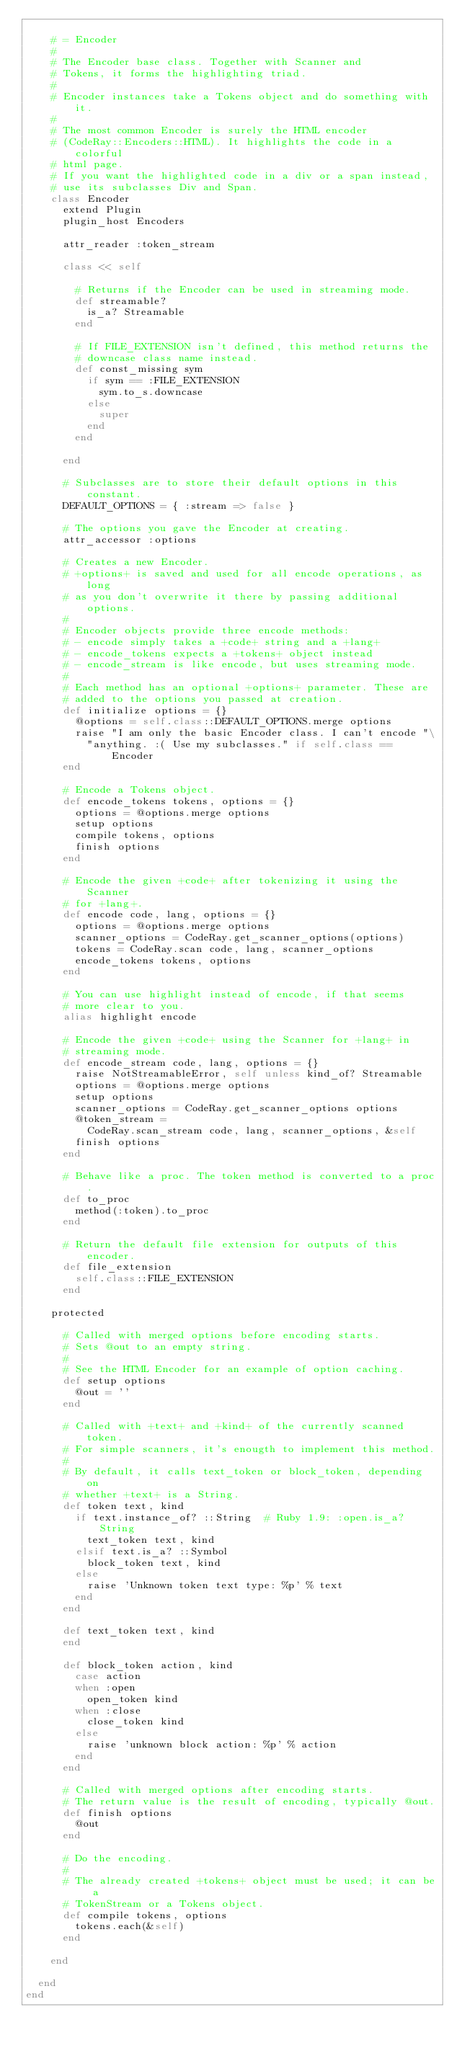Convert code to text. <code><loc_0><loc_0><loc_500><loc_500><_Ruby_>
    # = Encoder
    #
    # The Encoder base class. Together with Scanner and
    # Tokens, it forms the highlighting triad.
    #
    # Encoder instances take a Tokens object and do something with it.
    #
    # The most common Encoder is surely the HTML encoder
    # (CodeRay::Encoders::HTML). It highlights the code in a colorful
    # html page.
    # If you want the highlighted code in a div or a span instead,
    # use its subclasses Div and Span.
    class Encoder
      extend Plugin
      plugin_host Encoders

      attr_reader :token_stream

      class << self

        # Returns if the Encoder can be used in streaming mode.
        def streamable?
          is_a? Streamable
        end

        # If FILE_EXTENSION isn't defined, this method returns the
        # downcase class name instead.
        def const_missing sym
          if sym == :FILE_EXTENSION
            sym.to_s.downcase
          else
            super
          end
        end

      end

      # Subclasses are to store their default options in this constant.
      DEFAULT_OPTIONS = { :stream => false }

      # The options you gave the Encoder at creating.
      attr_accessor :options

      # Creates a new Encoder.
      # +options+ is saved and used for all encode operations, as long
      # as you don't overwrite it there by passing additional options.
      #
      # Encoder objects provide three encode methods:
      # - encode simply takes a +code+ string and a +lang+
      # - encode_tokens expects a +tokens+ object instead
      # - encode_stream is like encode, but uses streaming mode.
      #
      # Each method has an optional +options+ parameter. These are
      # added to the options you passed at creation.
      def initialize options = {}
        @options = self.class::DEFAULT_OPTIONS.merge options
        raise "I am only the basic Encoder class. I can't encode "\
          "anything. :( Use my subclasses." if self.class == Encoder
      end

      # Encode a Tokens object.
      def encode_tokens tokens, options = {}
        options = @options.merge options
        setup options
        compile tokens, options
        finish options
      end

      # Encode the given +code+ after tokenizing it using the Scanner
      # for +lang+.
      def encode code, lang, options = {}
        options = @options.merge options
        scanner_options = CodeRay.get_scanner_options(options)
        tokens = CodeRay.scan code, lang, scanner_options
        encode_tokens tokens, options
      end

      # You can use highlight instead of encode, if that seems
      # more clear to you.
      alias highlight encode

      # Encode the given +code+ using the Scanner for +lang+ in
      # streaming mode.
      def encode_stream code, lang, options = {}
        raise NotStreamableError, self unless kind_of? Streamable
        options = @options.merge options
        setup options
        scanner_options = CodeRay.get_scanner_options options
        @token_stream =
          CodeRay.scan_stream code, lang, scanner_options, &self
        finish options
      end

      # Behave like a proc. The token method is converted to a proc.
      def to_proc
        method(:token).to_proc
      end

      # Return the default file extension for outputs of this encoder.
      def file_extension
        self.class::FILE_EXTENSION
      end

    protected

      # Called with merged options before encoding starts.
      # Sets @out to an empty string.
      #
      # See the HTML Encoder for an example of option caching.
      def setup options
        @out = ''
      end

      # Called with +text+ and +kind+ of the currently scanned token.
      # For simple scanners, it's enougth to implement this method.
      #
      # By default, it calls text_token or block_token, depending on
      # whether +text+ is a String.
      def token text, kind
        if text.instance_of? ::String  # Ruby 1.9: :open.is_a? String
          text_token text, kind
        elsif text.is_a? ::Symbol
          block_token text, kind
        else
          raise 'Unknown token text type: %p' % text
        end
      end

      def text_token text, kind
      end

      def block_token action, kind
        case action
        when :open
          open_token kind
        when :close
          close_token kind
        else
          raise 'unknown block action: %p' % action
        end
      end

      # Called with merged options after encoding starts.
      # The return value is the result of encoding, typically @out.
      def finish options
        @out
      end

      # Do the encoding.
      #
      # The already created +tokens+ object must be used; it can be a
      # TokenStream or a Tokens object.
      def compile tokens, options
        tokens.each(&self)
      end

    end

  end
end
</code> 